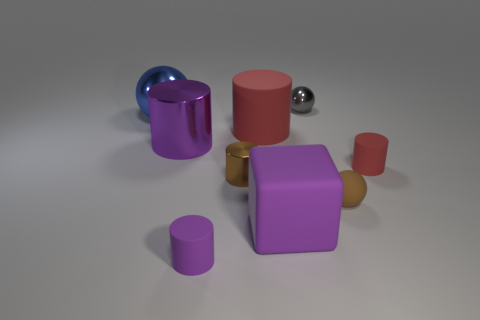Is there a large shiny object of the same color as the rubber sphere?
Provide a succinct answer. No. What is the color of the metal cylinder that is the same size as the blue metal ball?
Your response must be concise. Purple. Is the tiny purple rubber object the same shape as the blue object?
Make the answer very short. No. What material is the tiny brown object in front of the tiny brown metallic cylinder?
Provide a short and direct response. Rubber. The block has what color?
Provide a short and direct response. Purple. Does the metal object that is on the left side of the big shiny cylinder have the same size as the brown thing right of the block?
Give a very brief answer. No. There is a matte object that is on the left side of the cube and behind the big purple cube; what is its size?
Ensure brevity in your answer.  Large. What is the color of the other metal thing that is the same shape as the brown metal thing?
Your response must be concise. Purple. Are there more large metal objects to the right of the small brown rubber thing than gray metallic objects to the left of the large red rubber cylinder?
Your answer should be very brief. No. What number of other objects are the same shape as the tiny red thing?
Offer a very short reply. 4. 